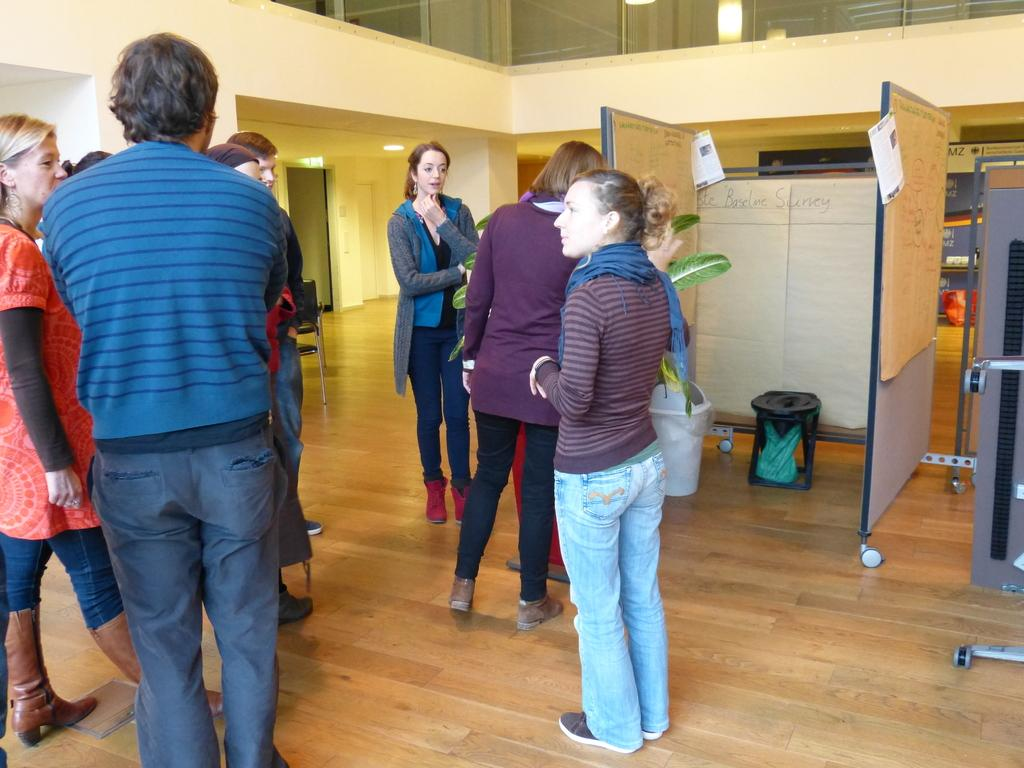What can be seen in the image? There are people standing in the image. What is visible in the background of the image? In the background, there are boards, papers, bins, stands, lights, windows, and a wall. What is the surface on which the people are standing? There is a floor at the bottom of the image. What type of bulb is being used by the people in the image? There is no mention of a bulb in the image; the lights visible in the background are not described in detail. What kind of hat is being worn by the people in the image? There is no mention of a hat in the image; the people's attire is not described in detail. 